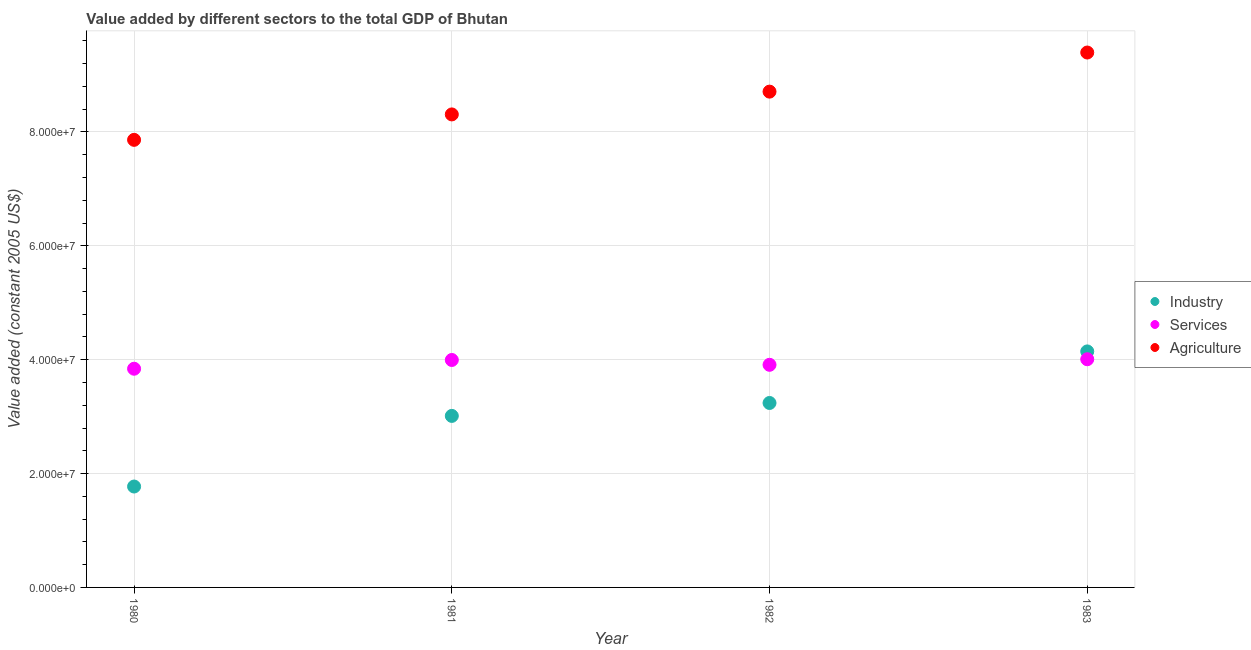How many different coloured dotlines are there?
Provide a short and direct response. 3. What is the value added by agricultural sector in 1980?
Your answer should be compact. 7.86e+07. Across all years, what is the maximum value added by services?
Your answer should be compact. 4.01e+07. Across all years, what is the minimum value added by industrial sector?
Provide a short and direct response. 1.77e+07. What is the total value added by services in the graph?
Your answer should be very brief. 1.58e+08. What is the difference between the value added by industrial sector in 1980 and that in 1981?
Make the answer very short. -1.24e+07. What is the difference between the value added by industrial sector in 1982 and the value added by agricultural sector in 1983?
Keep it short and to the point. -6.16e+07. What is the average value added by services per year?
Your response must be concise. 3.94e+07. In the year 1981, what is the difference between the value added by industrial sector and value added by services?
Offer a very short reply. -9.82e+06. In how many years, is the value added by industrial sector greater than 44000000 US$?
Offer a terse response. 0. What is the ratio of the value added by agricultural sector in 1981 to that in 1983?
Provide a succinct answer. 0.88. What is the difference between the highest and the second highest value added by agricultural sector?
Your response must be concise. 6.87e+06. What is the difference between the highest and the lowest value added by services?
Your answer should be very brief. 1.67e+06. In how many years, is the value added by agricultural sector greater than the average value added by agricultural sector taken over all years?
Provide a succinct answer. 2. Is it the case that in every year, the sum of the value added by industrial sector and value added by services is greater than the value added by agricultural sector?
Ensure brevity in your answer.  No. Is the value added by industrial sector strictly greater than the value added by agricultural sector over the years?
Your response must be concise. No. Is the value added by industrial sector strictly less than the value added by agricultural sector over the years?
Ensure brevity in your answer.  Yes. How many dotlines are there?
Offer a very short reply. 3. How many years are there in the graph?
Your answer should be very brief. 4. Are the values on the major ticks of Y-axis written in scientific E-notation?
Your answer should be very brief. Yes. Where does the legend appear in the graph?
Offer a very short reply. Center right. How many legend labels are there?
Ensure brevity in your answer.  3. What is the title of the graph?
Ensure brevity in your answer.  Value added by different sectors to the total GDP of Bhutan. What is the label or title of the Y-axis?
Offer a terse response. Value added (constant 2005 US$). What is the Value added (constant 2005 US$) of Industry in 1980?
Give a very brief answer. 1.77e+07. What is the Value added (constant 2005 US$) in Services in 1980?
Keep it short and to the point. 3.84e+07. What is the Value added (constant 2005 US$) in Agriculture in 1980?
Provide a short and direct response. 7.86e+07. What is the Value added (constant 2005 US$) of Industry in 1981?
Provide a succinct answer. 3.01e+07. What is the Value added (constant 2005 US$) of Services in 1981?
Ensure brevity in your answer.  3.99e+07. What is the Value added (constant 2005 US$) of Agriculture in 1981?
Give a very brief answer. 8.31e+07. What is the Value added (constant 2005 US$) of Industry in 1982?
Provide a succinct answer. 3.24e+07. What is the Value added (constant 2005 US$) of Services in 1982?
Your answer should be very brief. 3.91e+07. What is the Value added (constant 2005 US$) of Agriculture in 1982?
Ensure brevity in your answer.  8.71e+07. What is the Value added (constant 2005 US$) of Industry in 1983?
Provide a short and direct response. 4.15e+07. What is the Value added (constant 2005 US$) in Services in 1983?
Offer a very short reply. 4.01e+07. What is the Value added (constant 2005 US$) of Agriculture in 1983?
Your answer should be very brief. 9.39e+07. Across all years, what is the maximum Value added (constant 2005 US$) of Industry?
Offer a terse response. 4.15e+07. Across all years, what is the maximum Value added (constant 2005 US$) in Services?
Your answer should be compact. 4.01e+07. Across all years, what is the maximum Value added (constant 2005 US$) of Agriculture?
Your response must be concise. 9.39e+07. Across all years, what is the minimum Value added (constant 2005 US$) of Industry?
Provide a short and direct response. 1.77e+07. Across all years, what is the minimum Value added (constant 2005 US$) of Services?
Your response must be concise. 3.84e+07. Across all years, what is the minimum Value added (constant 2005 US$) in Agriculture?
Keep it short and to the point. 7.86e+07. What is the total Value added (constant 2005 US$) in Industry in the graph?
Give a very brief answer. 1.22e+08. What is the total Value added (constant 2005 US$) of Services in the graph?
Your answer should be compact. 1.58e+08. What is the total Value added (constant 2005 US$) in Agriculture in the graph?
Provide a succinct answer. 3.43e+08. What is the difference between the Value added (constant 2005 US$) of Industry in 1980 and that in 1981?
Your response must be concise. -1.24e+07. What is the difference between the Value added (constant 2005 US$) of Services in 1980 and that in 1981?
Your response must be concise. -1.54e+06. What is the difference between the Value added (constant 2005 US$) of Agriculture in 1980 and that in 1981?
Provide a short and direct response. -4.47e+06. What is the difference between the Value added (constant 2005 US$) in Industry in 1980 and that in 1982?
Offer a terse response. -1.47e+07. What is the difference between the Value added (constant 2005 US$) of Services in 1980 and that in 1982?
Provide a succinct answer. -6.89e+05. What is the difference between the Value added (constant 2005 US$) of Agriculture in 1980 and that in 1982?
Make the answer very short. -8.47e+06. What is the difference between the Value added (constant 2005 US$) in Industry in 1980 and that in 1983?
Give a very brief answer. -2.37e+07. What is the difference between the Value added (constant 2005 US$) in Services in 1980 and that in 1983?
Provide a short and direct response. -1.67e+06. What is the difference between the Value added (constant 2005 US$) of Agriculture in 1980 and that in 1983?
Your answer should be compact. -1.53e+07. What is the difference between the Value added (constant 2005 US$) of Industry in 1981 and that in 1982?
Offer a terse response. -2.27e+06. What is the difference between the Value added (constant 2005 US$) of Services in 1981 and that in 1982?
Give a very brief answer. 8.48e+05. What is the difference between the Value added (constant 2005 US$) of Agriculture in 1981 and that in 1982?
Keep it short and to the point. -4.00e+06. What is the difference between the Value added (constant 2005 US$) of Industry in 1981 and that in 1983?
Your answer should be compact. -1.13e+07. What is the difference between the Value added (constant 2005 US$) in Services in 1981 and that in 1983?
Provide a succinct answer. -1.29e+05. What is the difference between the Value added (constant 2005 US$) in Agriculture in 1981 and that in 1983?
Give a very brief answer. -1.09e+07. What is the difference between the Value added (constant 2005 US$) in Industry in 1982 and that in 1983?
Keep it short and to the point. -9.05e+06. What is the difference between the Value added (constant 2005 US$) of Services in 1982 and that in 1983?
Give a very brief answer. -9.77e+05. What is the difference between the Value added (constant 2005 US$) in Agriculture in 1982 and that in 1983?
Provide a short and direct response. -6.87e+06. What is the difference between the Value added (constant 2005 US$) in Industry in 1980 and the Value added (constant 2005 US$) in Services in 1981?
Keep it short and to the point. -2.22e+07. What is the difference between the Value added (constant 2005 US$) in Industry in 1980 and the Value added (constant 2005 US$) in Agriculture in 1981?
Keep it short and to the point. -6.54e+07. What is the difference between the Value added (constant 2005 US$) in Services in 1980 and the Value added (constant 2005 US$) in Agriculture in 1981?
Offer a terse response. -4.47e+07. What is the difference between the Value added (constant 2005 US$) in Industry in 1980 and the Value added (constant 2005 US$) in Services in 1982?
Your response must be concise. -2.14e+07. What is the difference between the Value added (constant 2005 US$) of Industry in 1980 and the Value added (constant 2005 US$) of Agriculture in 1982?
Offer a terse response. -6.94e+07. What is the difference between the Value added (constant 2005 US$) in Services in 1980 and the Value added (constant 2005 US$) in Agriculture in 1982?
Ensure brevity in your answer.  -4.87e+07. What is the difference between the Value added (constant 2005 US$) in Industry in 1980 and the Value added (constant 2005 US$) in Services in 1983?
Give a very brief answer. -2.24e+07. What is the difference between the Value added (constant 2005 US$) of Industry in 1980 and the Value added (constant 2005 US$) of Agriculture in 1983?
Provide a succinct answer. -7.62e+07. What is the difference between the Value added (constant 2005 US$) in Services in 1980 and the Value added (constant 2005 US$) in Agriculture in 1983?
Provide a short and direct response. -5.55e+07. What is the difference between the Value added (constant 2005 US$) in Industry in 1981 and the Value added (constant 2005 US$) in Services in 1982?
Ensure brevity in your answer.  -8.97e+06. What is the difference between the Value added (constant 2005 US$) in Industry in 1981 and the Value added (constant 2005 US$) in Agriculture in 1982?
Provide a short and direct response. -5.70e+07. What is the difference between the Value added (constant 2005 US$) in Services in 1981 and the Value added (constant 2005 US$) in Agriculture in 1982?
Ensure brevity in your answer.  -4.71e+07. What is the difference between the Value added (constant 2005 US$) of Industry in 1981 and the Value added (constant 2005 US$) of Services in 1983?
Give a very brief answer. -9.95e+06. What is the difference between the Value added (constant 2005 US$) in Industry in 1981 and the Value added (constant 2005 US$) in Agriculture in 1983?
Your answer should be very brief. -6.38e+07. What is the difference between the Value added (constant 2005 US$) in Services in 1981 and the Value added (constant 2005 US$) in Agriculture in 1983?
Offer a terse response. -5.40e+07. What is the difference between the Value added (constant 2005 US$) in Industry in 1982 and the Value added (constant 2005 US$) in Services in 1983?
Provide a succinct answer. -7.68e+06. What is the difference between the Value added (constant 2005 US$) of Industry in 1982 and the Value added (constant 2005 US$) of Agriculture in 1983?
Keep it short and to the point. -6.16e+07. What is the difference between the Value added (constant 2005 US$) in Services in 1982 and the Value added (constant 2005 US$) in Agriculture in 1983?
Provide a succinct answer. -5.48e+07. What is the average Value added (constant 2005 US$) in Industry per year?
Offer a very short reply. 3.04e+07. What is the average Value added (constant 2005 US$) of Services per year?
Provide a short and direct response. 3.94e+07. What is the average Value added (constant 2005 US$) of Agriculture per year?
Offer a terse response. 8.57e+07. In the year 1980, what is the difference between the Value added (constant 2005 US$) of Industry and Value added (constant 2005 US$) of Services?
Provide a short and direct response. -2.07e+07. In the year 1980, what is the difference between the Value added (constant 2005 US$) in Industry and Value added (constant 2005 US$) in Agriculture?
Provide a succinct answer. -6.09e+07. In the year 1980, what is the difference between the Value added (constant 2005 US$) of Services and Value added (constant 2005 US$) of Agriculture?
Offer a very short reply. -4.02e+07. In the year 1981, what is the difference between the Value added (constant 2005 US$) of Industry and Value added (constant 2005 US$) of Services?
Keep it short and to the point. -9.82e+06. In the year 1981, what is the difference between the Value added (constant 2005 US$) in Industry and Value added (constant 2005 US$) in Agriculture?
Offer a terse response. -5.30e+07. In the year 1981, what is the difference between the Value added (constant 2005 US$) of Services and Value added (constant 2005 US$) of Agriculture?
Your answer should be very brief. -4.31e+07. In the year 1982, what is the difference between the Value added (constant 2005 US$) of Industry and Value added (constant 2005 US$) of Services?
Your answer should be compact. -6.70e+06. In the year 1982, what is the difference between the Value added (constant 2005 US$) of Industry and Value added (constant 2005 US$) of Agriculture?
Your answer should be very brief. -5.47e+07. In the year 1982, what is the difference between the Value added (constant 2005 US$) in Services and Value added (constant 2005 US$) in Agriculture?
Your response must be concise. -4.80e+07. In the year 1983, what is the difference between the Value added (constant 2005 US$) of Industry and Value added (constant 2005 US$) of Services?
Your answer should be compact. 1.37e+06. In the year 1983, what is the difference between the Value added (constant 2005 US$) in Industry and Value added (constant 2005 US$) in Agriculture?
Offer a terse response. -5.25e+07. In the year 1983, what is the difference between the Value added (constant 2005 US$) in Services and Value added (constant 2005 US$) in Agriculture?
Give a very brief answer. -5.39e+07. What is the ratio of the Value added (constant 2005 US$) of Industry in 1980 to that in 1981?
Offer a very short reply. 0.59. What is the ratio of the Value added (constant 2005 US$) of Services in 1980 to that in 1981?
Offer a very short reply. 0.96. What is the ratio of the Value added (constant 2005 US$) in Agriculture in 1980 to that in 1981?
Your answer should be very brief. 0.95. What is the ratio of the Value added (constant 2005 US$) of Industry in 1980 to that in 1982?
Ensure brevity in your answer.  0.55. What is the ratio of the Value added (constant 2005 US$) in Services in 1980 to that in 1982?
Provide a short and direct response. 0.98. What is the ratio of the Value added (constant 2005 US$) in Agriculture in 1980 to that in 1982?
Your response must be concise. 0.9. What is the ratio of the Value added (constant 2005 US$) in Industry in 1980 to that in 1983?
Offer a very short reply. 0.43. What is the ratio of the Value added (constant 2005 US$) of Services in 1980 to that in 1983?
Offer a terse response. 0.96. What is the ratio of the Value added (constant 2005 US$) of Agriculture in 1980 to that in 1983?
Your answer should be very brief. 0.84. What is the ratio of the Value added (constant 2005 US$) in Industry in 1981 to that in 1982?
Ensure brevity in your answer.  0.93. What is the ratio of the Value added (constant 2005 US$) in Services in 1981 to that in 1982?
Provide a succinct answer. 1.02. What is the ratio of the Value added (constant 2005 US$) in Agriculture in 1981 to that in 1982?
Give a very brief answer. 0.95. What is the ratio of the Value added (constant 2005 US$) in Industry in 1981 to that in 1983?
Give a very brief answer. 0.73. What is the ratio of the Value added (constant 2005 US$) of Services in 1981 to that in 1983?
Offer a very short reply. 1. What is the ratio of the Value added (constant 2005 US$) of Agriculture in 1981 to that in 1983?
Keep it short and to the point. 0.88. What is the ratio of the Value added (constant 2005 US$) of Industry in 1982 to that in 1983?
Make the answer very short. 0.78. What is the ratio of the Value added (constant 2005 US$) in Services in 1982 to that in 1983?
Your answer should be very brief. 0.98. What is the ratio of the Value added (constant 2005 US$) in Agriculture in 1982 to that in 1983?
Provide a succinct answer. 0.93. What is the difference between the highest and the second highest Value added (constant 2005 US$) in Industry?
Your response must be concise. 9.05e+06. What is the difference between the highest and the second highest Value added (constant 2005 US$) of Services?
Your response must be concise. 1.29e+05. What is the difference between the highest and the second highest Value added (constant 2005 US$) in Agriculture?
Give a very brief answer. 6.87e+06. What is the difference between the highest and the lowest Value added (constant 2005 US$) in Industry?
Your answer should be very brief. 2.37e+07. What is the difference between the highest and the lowest Value added (constant 2005 US$) in Services?
Give a very brief answer. 1.67e+06. What is the difference between the highest and the lowest Value added (constant 2005 US$) of Agriculture?
Offer a very short reply. 1.53e+07. 